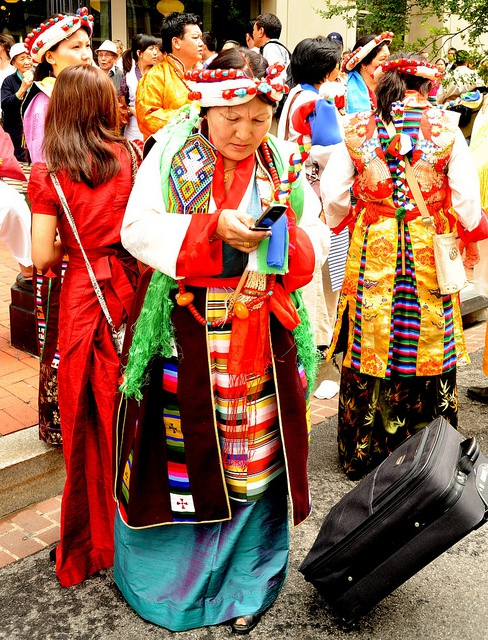Describe the objects in this image and their specific colors. I can see people in black, ivory, red, and maroon tones, people in black, ivory, orange, and red tones, people in black, red, and maroon tones, suitcase in black, darkgray, and gray tones, and people in black, white, lightblue, and red tones in this image. 